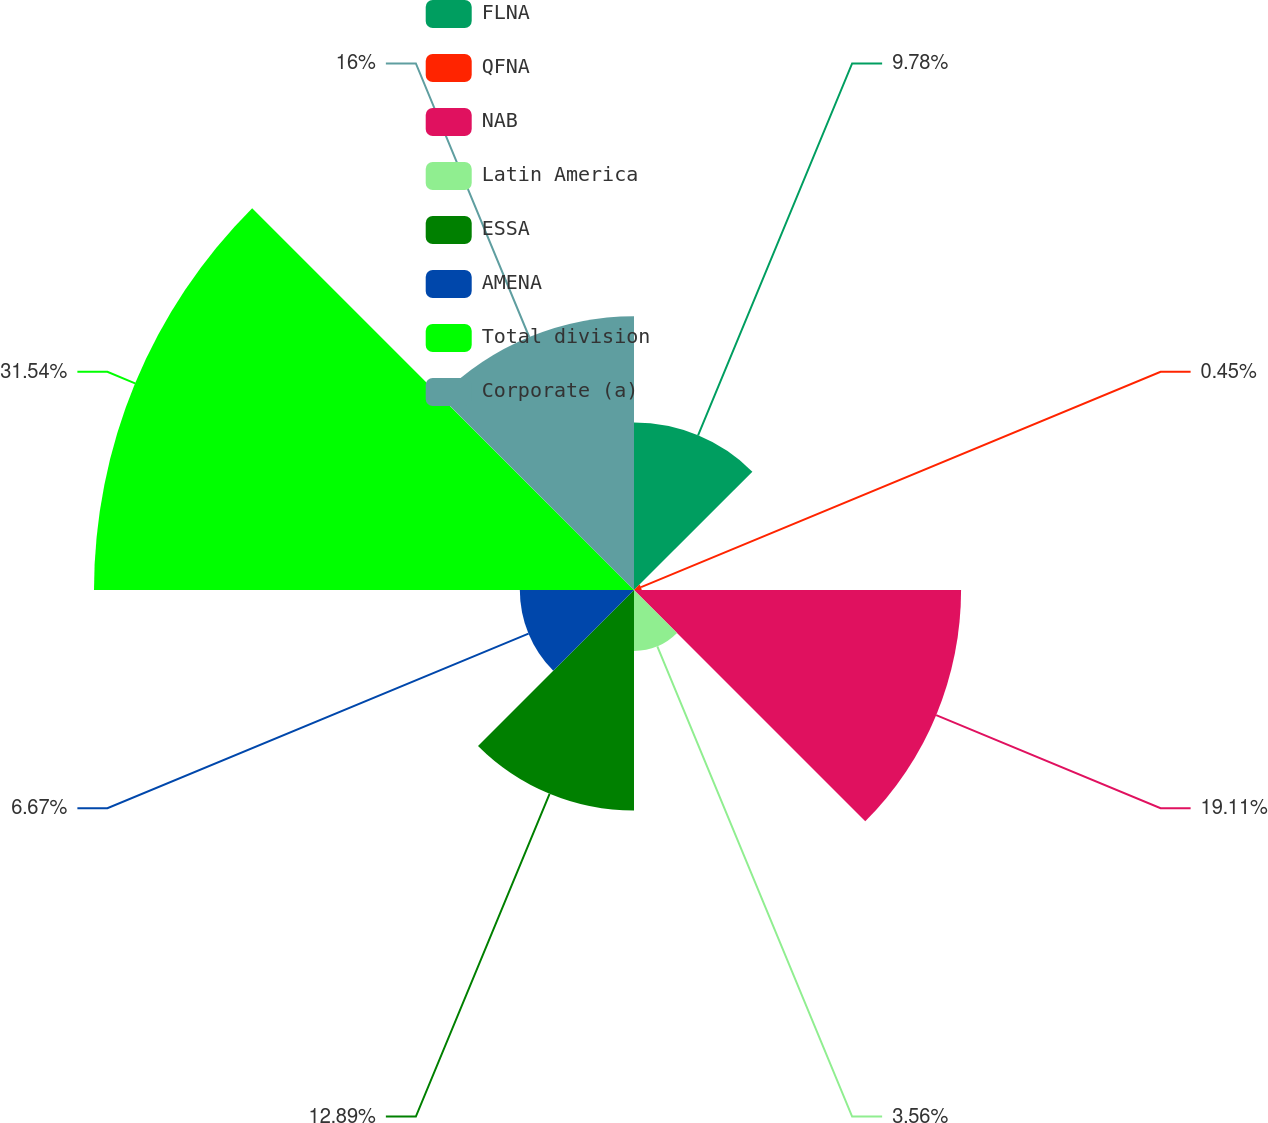<chart> <loc_0><loc_0><loc_500><loc_500><pie_chart><fcel>FLNA<fcel>QFNA<fcel>NAB<fcel>Latin America<fcel>ESSA<fcel>AMENA<fcel>Total division<fcel>Corporate (a)<nl><fcel>9.78%<fcel>0.45%<fcel>19.11%<fcel>3.56%<fcel>12.89%<fcel>6.67%<fcel>31.55%<fcel>16.0%<nl></chart> 